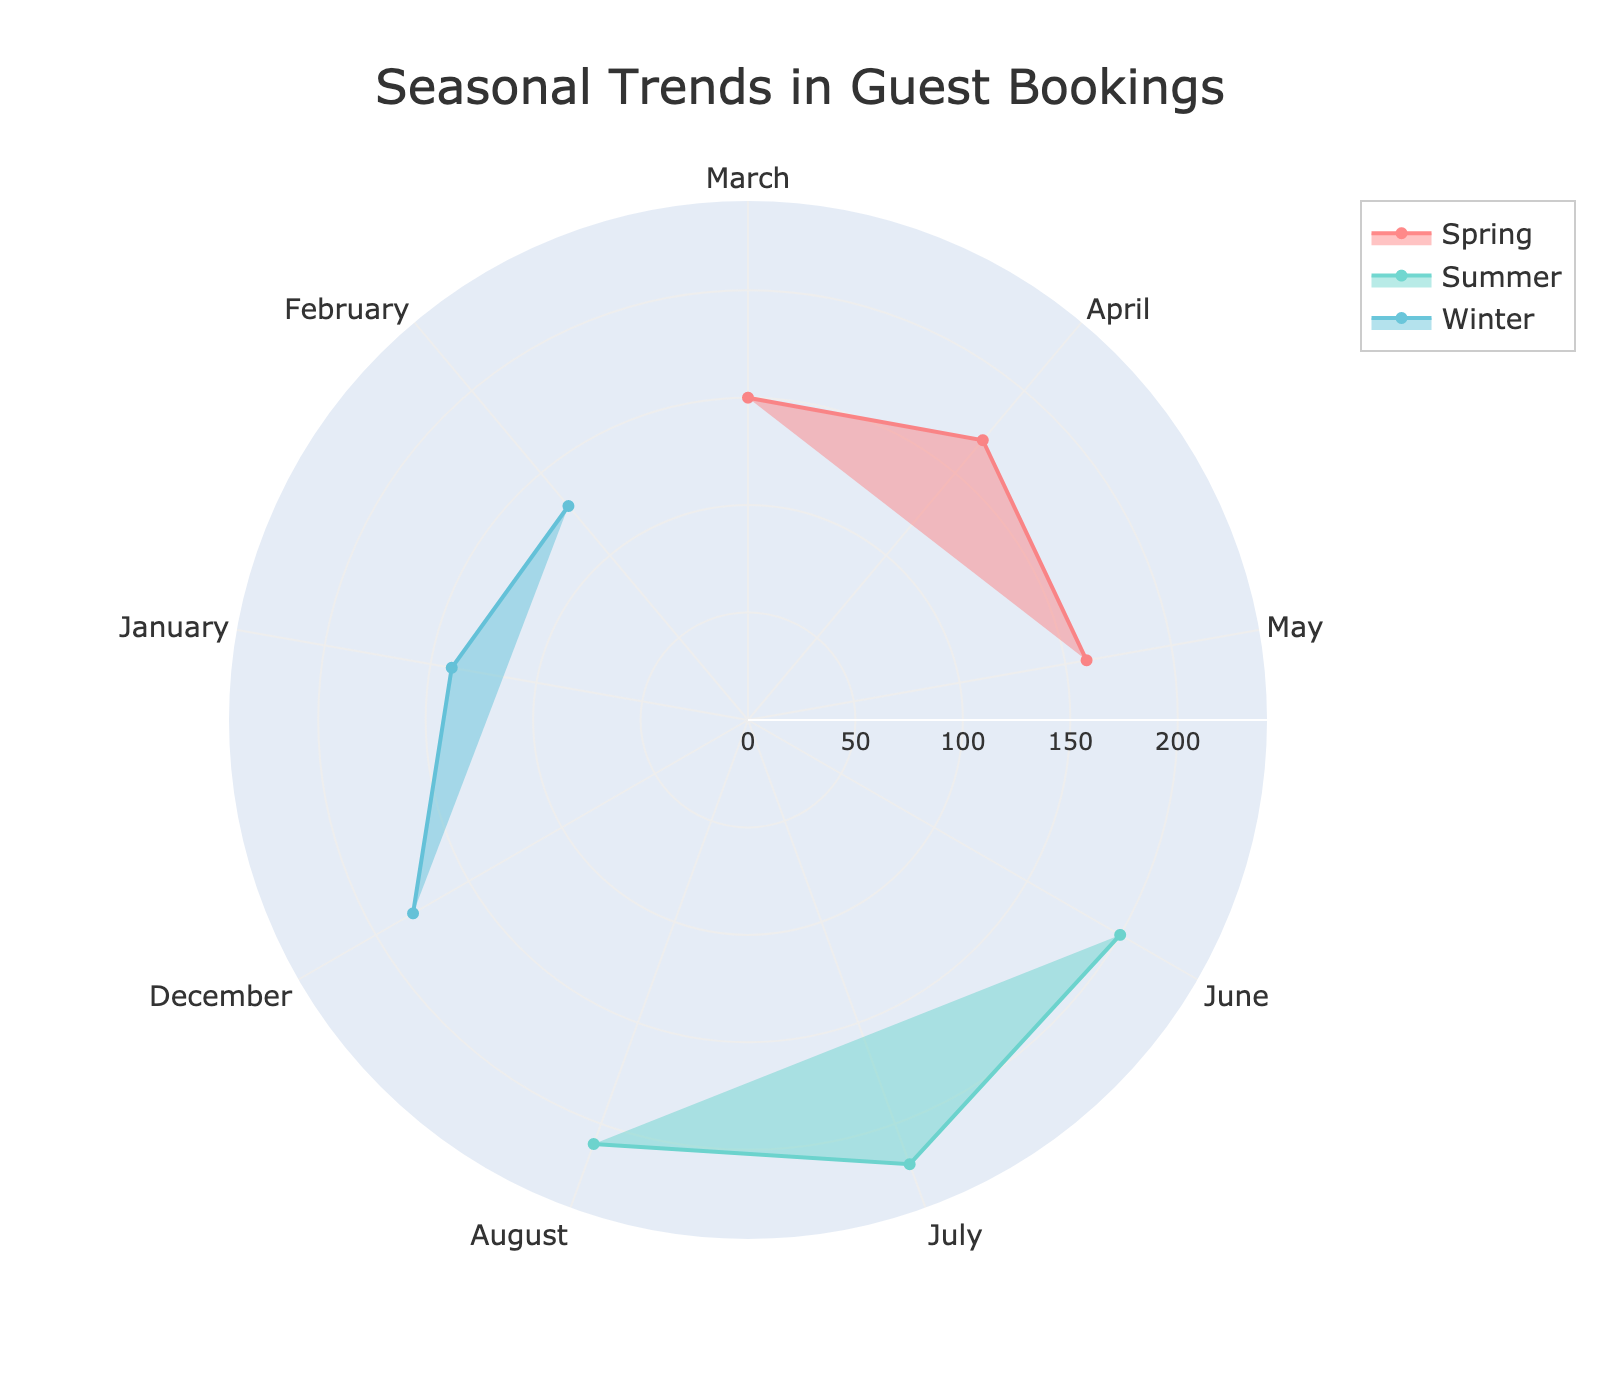What is the title of the radar chart? The title of the radar chart is displayed at the top, prominently and clearly.
Answer: Seasonal Trends in Guest Bookings What is the maximum value for summer average bookings? Inspect the radial points for summer across June, July, and August. The highest point among them is for July.
Answer: 220 Which season has the highest average bookings overall? Compare the highest points of each season. Summer has the highest point with an average booking of 220 in July.
Answer: Summer In which month does spring receive the highest bookings? Look at the points corresponding to the spring months, which are March, April, and May. The highest is April.
Answer: April How many months are represented in the radar chart? Count the distinct segments on the angular axis which represent each month. There are nine months displayed.
Answer: 9 What is the difference in average bookings between December and January? Note the values for December and January (180 and 140 respectively), then subtract January's value from December's.
Answer: 40 Which season has the least variability in average bookings? Compare the range of booking values within each season. Spring ranges from 150 to 170, Summer from 200 to 220, and Winter from 130 to 180. Spring has the smallest range.
Answer: Spring During which month does winter experience the lowest bookings? Look at the values for the winter months—January, February, and December. The lowest value is for February.
Answer: February Compare the average bookings between May and August. Which month has higher bookings? Inspect the average bookings for May and August. May has 160, while August has 210.
Answer: August How does the seasonal trend of winter bookings compare to summer bookings? Evaluate the pattern and range of bookings for both seasons. Winter has a lower range (130-180) and an upward trend from February to December. Summer has a higher range (200-220) and more stable high bookings across its months.
Answer: Winter has lower and more variable bookings compared to Summer 